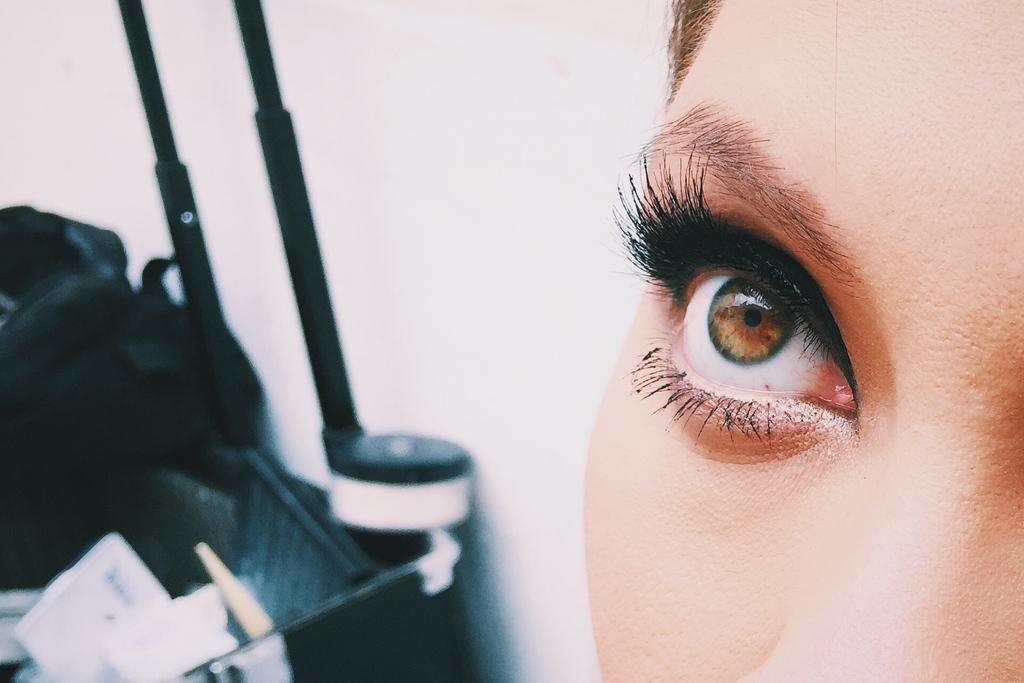What part of a person's face is visible in the foreground of the image? There is a person's eye, forehead, and cheek in the foreground of the image. On which side of the image are the person's facial features located? The person's facial features are on the right side of the image. What can be seen in the background of the image? There is a wall and black objects in the background of the image. Can you see the person jumping in the image? There is no indication of the person jumping in the image; only their facial features are visible. 